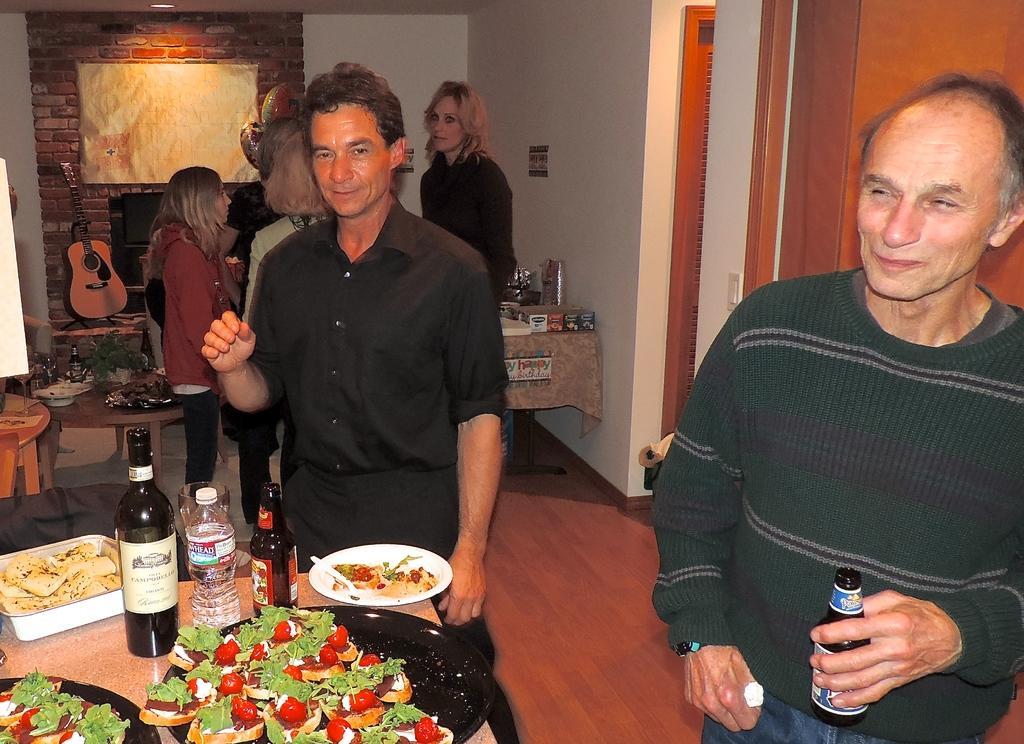How would you summarize this image in a sentence or two? In this image we can see this person wearing a sweater is holding a bottle with the label on it and this person wearing black shirt is standing near the table. Here we can see some food item are kept on the place and we can see bottles and glasses. In the background, we can see a few more people, we can see guitar, brick wall, fireplace and ceiling lights. 